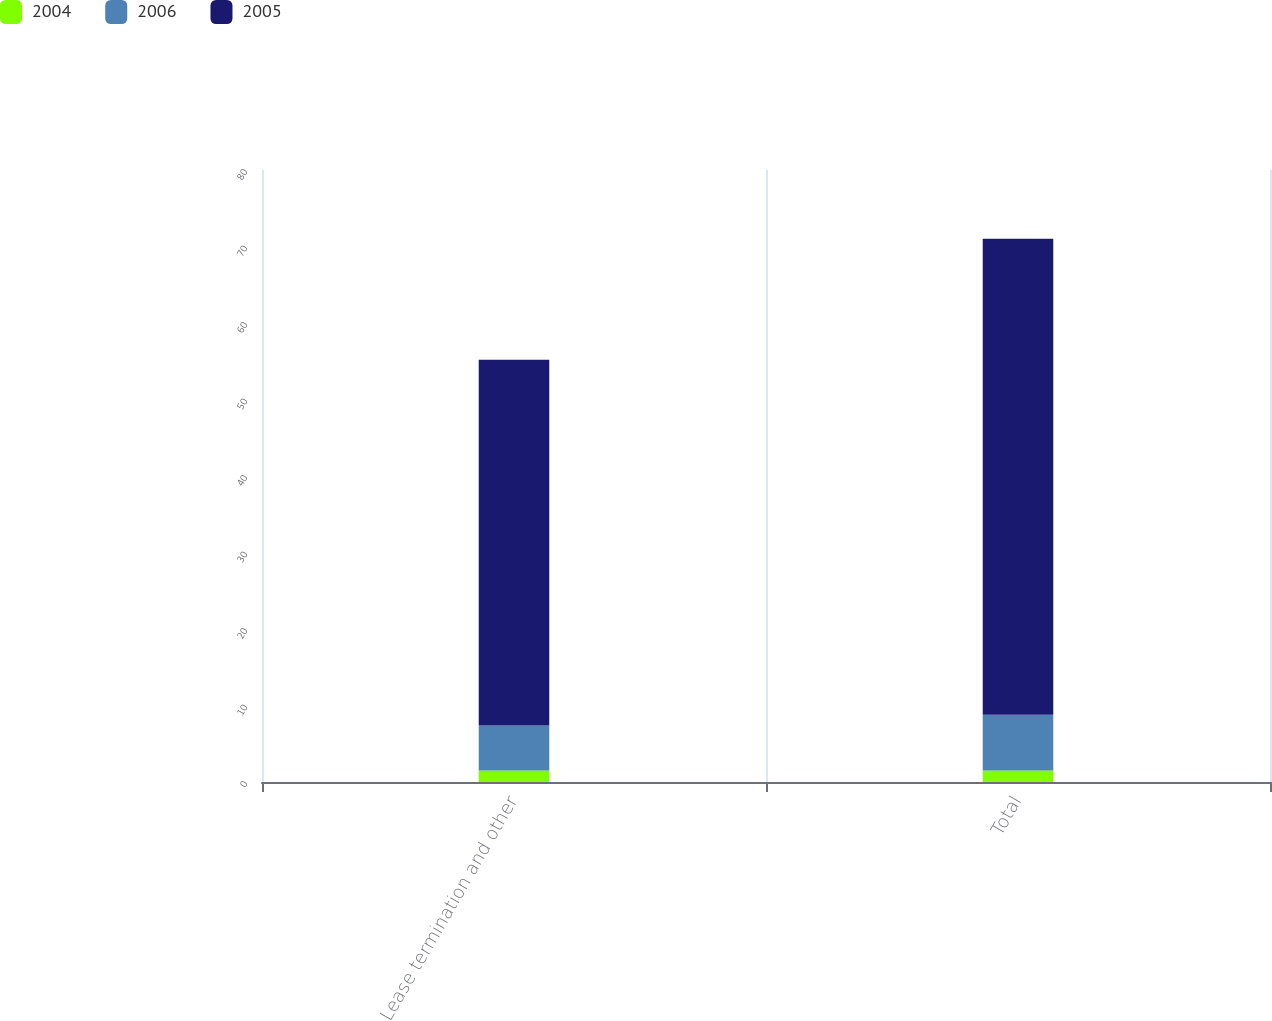Convert chart to OTSL. <chart><loc_0><loc_0><loc_500><loc_500><stacked_bar_chart><ecel><fcel>Lease termination and other<fcel>Total<nl><fcel>2004<fcel>1.5<fcel>1.5<nl><fcel>2006<fcel>5.9<fcel>7.3<nl><fcel>2005<fcel>47.8<fcel>62.2<nl></chart> 